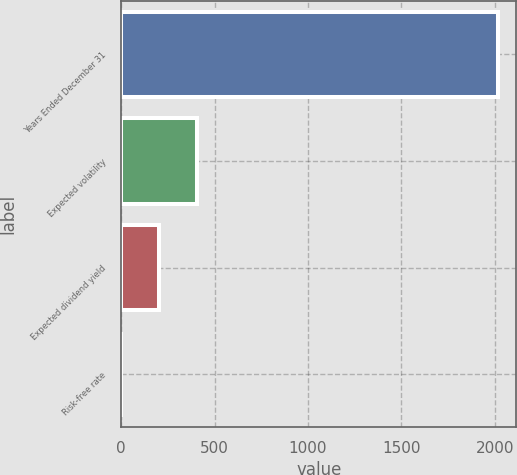<chart> <loc_0><loc_0><loc_500><loc_500><bar_chart><fcel>Years Ended December 31<fcel>Expected volatility<fcel>Expected dividend yield<fcel>Risk-free rate<nl><fcel>2015<fcel>403.64<fcel>202.22<fcel>0.8<nl></chart> 